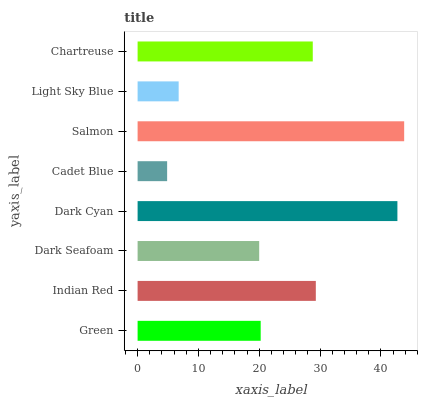Is Cadet Blue the minimum?
Answer yes or no. Yes. Is Salmon the maximum?
Answer yes or no. Yes. Is Indian Red the minimum?
Answer yes or no. No. Is Indian Red the maximum?
Answer yes or no. No. Is Indian Red greater than Green?
Answer yes or no. Yes. Is Green less than Indian Red?
Answer yes or no. Yes. Is Green greater than Indian Red?
Answer yes or no. No. Is Indian Red less than Green?
Answer yes or no. No. Is Chartreuse the high median?
Answer yes or no. Yes. Is Green the low median?
Answer yes or no. Yes. Is Dark Seafoam the high median?
Answer yes or no. No. Is Chartreuse the low median?
Answer yes or no. No. 